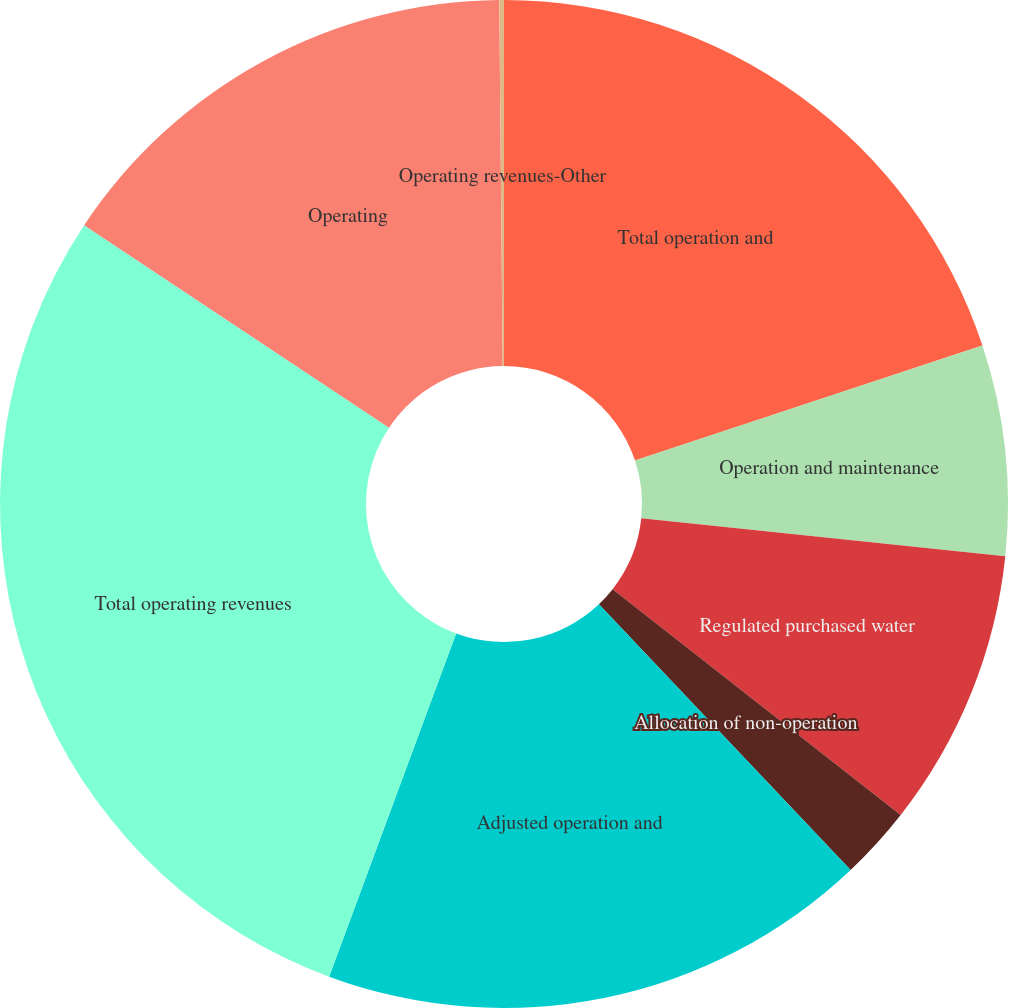Convert chart. <chart><loc_0><loc_0><loc_500><loc_500><pie_chart><fcel>Total operation and<fcel>Operation and maintenance<fcel>Regulated purchased water<fcel>Allocation of non-operation<fcel>Adjusted operation and<fcel>Total operating revenues<fcel>Operating<fcel>Operating revenues-Other<nl><fcel>19.91%<fcel>6.74%<fcel>8.93%<fcel>2.35%<fcel>17.71%<fcel>28.69%<fcel>15.52%<fcel>0.15%<nl></chart> 